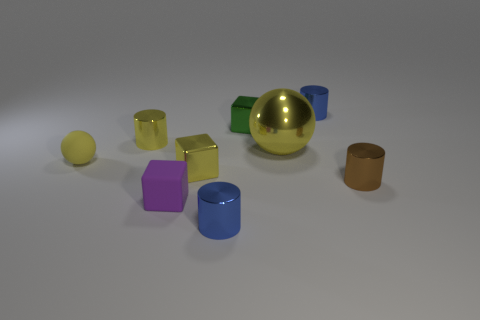Are there any other things that have the same size as the metal sphere?
Your answer should be very brief. No. Are the tiny blue cylinder that is to the left of the large thing and the tiny blue cylinder behind the small yellow metallic cylinder made of the same material?
Provide a short and direct response. Yes. There is a tiny blue metal cylinder that is in front of the tiny yellow sphere; how many green blocks are behind it?
Your response must be concise. 1. Do the rubber thing that is behind the tiny rubber block and the small blue shiny object that is on the right side of the large ball have the same shape?
Ensure brevity in your answer.  No. There is a yellow metallic object that is in front of the yellow cylinder and behind the small rubber ball; how big is it?
Ensure brevity in your answer.  Large. What color is the large metal object that is the same shape as the yellow rubber object?
Provide a succinct answer. Yellow. There is a small matte object in front of the tiny rubber object that is behind the brown cylinder; what color is it?
Keep it short and to the point. Purple. The tiny brown metal object has what shape?
Offer a terse response. Cylinder. There is a tiny yellow thing that is right of the small yellow matte thing and behind the small yellow block; what is its shape?
Provide a succinct answer. Cylinder. There is another thing that is made of the same material as the tiny purple object; what is its color?
Give a very brief answer. Yellow. 